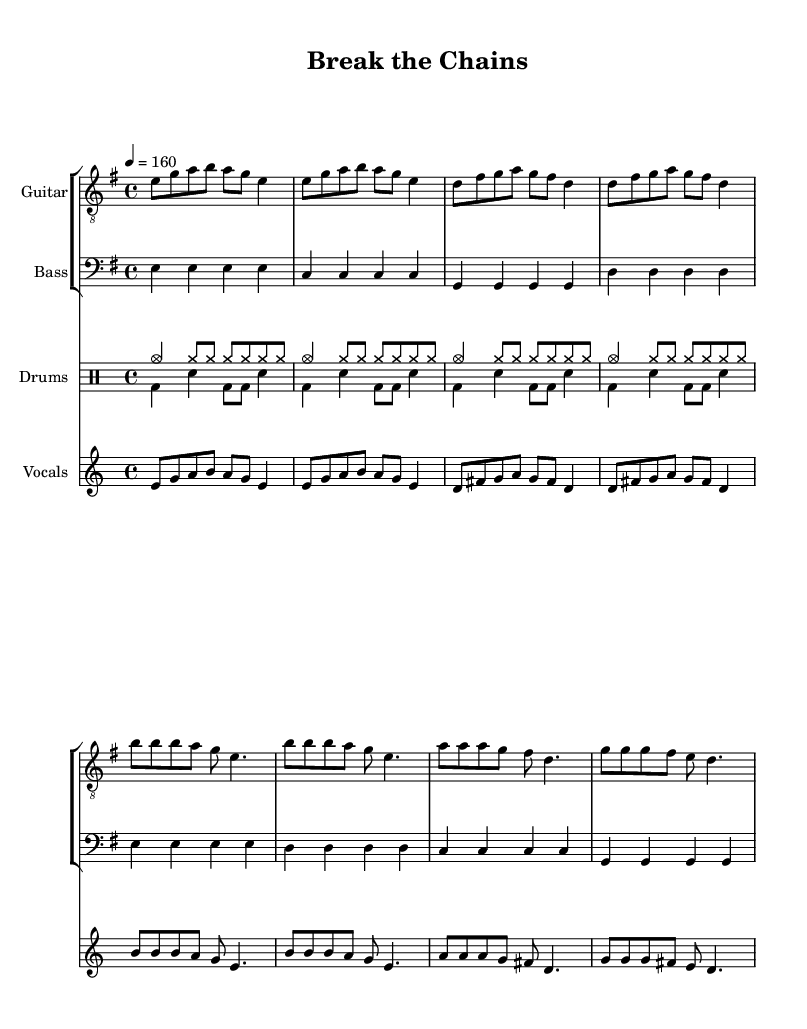What is the key signature of this music? The key signature is E minor, which contains one sharp (F#). This is indicated at the beginning of the score where the sharps are marked.
Answer: E minor What is the time signature of this music? The time signature is 4/4, shown at the beginning of the piece. This indicates that there are four beats in each measure and the quarter note gets one beat.
Answer: 4/4 What is the tempo of this music? The tempo marking is 160 beats per minute, indicated at the start of the score. This means the piece should be played at a fast pace.
Answer: 160 How many measures are there in the verse? The verse consists of four measures, detailed in the notation as there are four groups of notes separated by vertical lines.
Answer: Four What instrument is playing the bass part? The bass part is notated on a separate staff labeled "Bass" and uses the bass clef, indicating that it is performed by a bass instrument such as an electric bass guitar.
Answer: Bass What is the main theme expressed in the lyrics? The lyrics express a theme of rebellion against societal norms, indicated by phrases like "break the chains" and "rise up and be free," reflecting the punk ethos of challenging authority.
Answer: Rebellion What type of drum rhythm is used in the 'drumsDown' section? The 'drumsDown' section features a bass drum and snare drum pattern, emphasizing a traditional rock beat with regular alternation between bass and snare.
Answer: Rock beat 